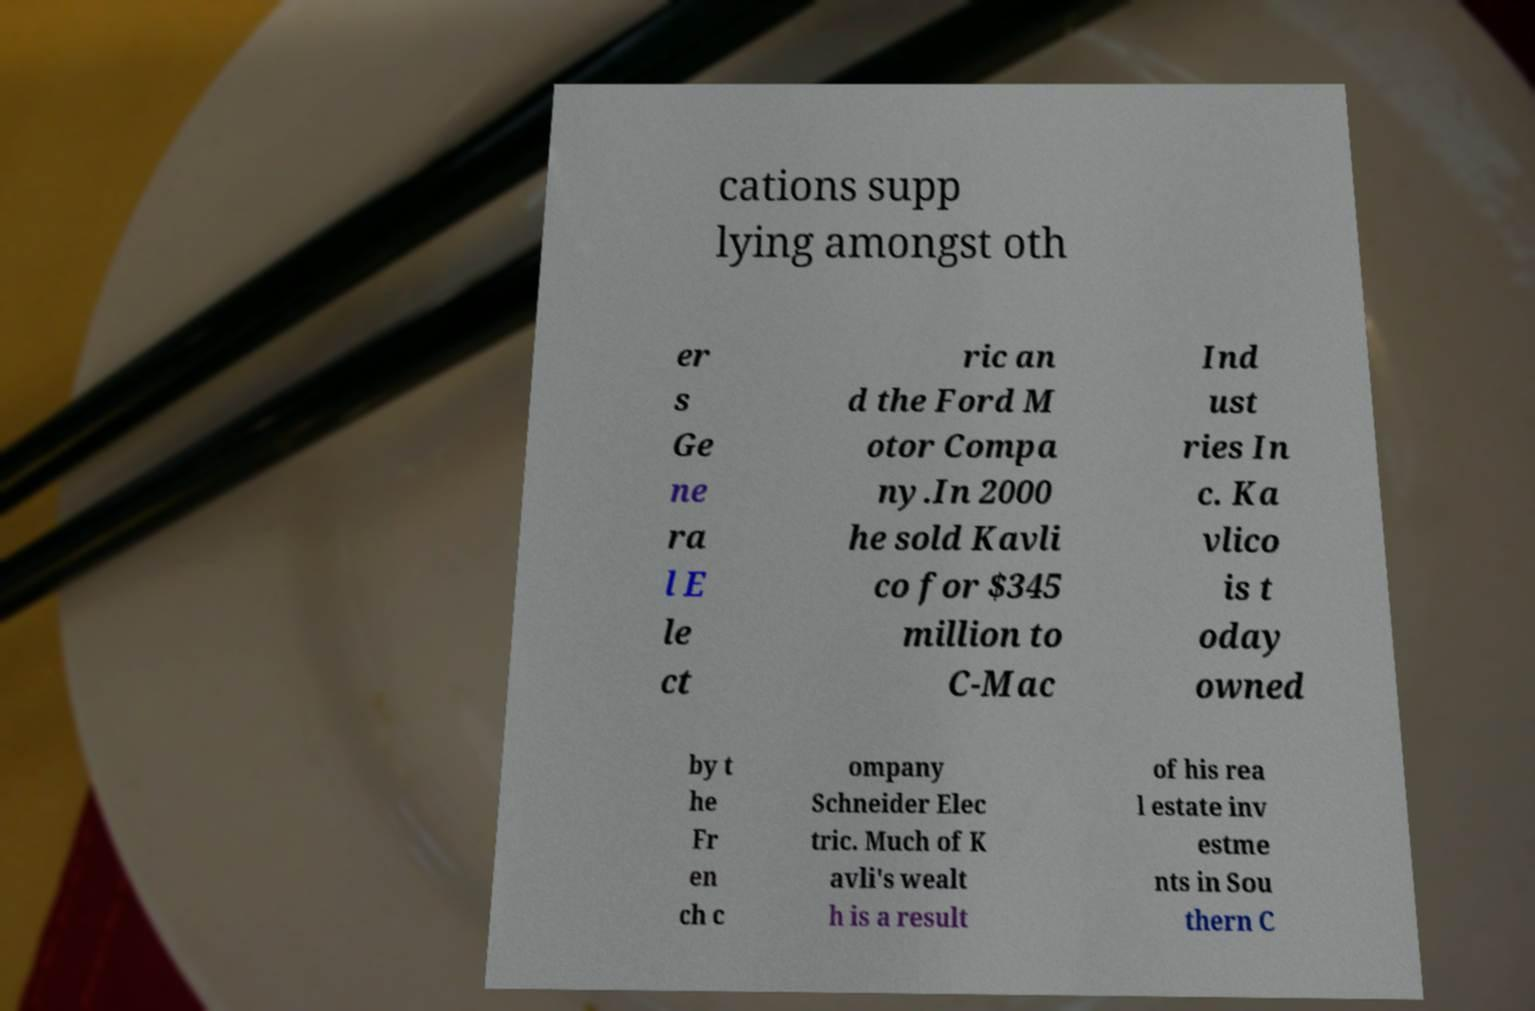I need the written content from this picture converted into text. Can you do that? cations supp lying amongst oth er s Ge ne ra l E le ct ric an d the Ford M otor Compa ny.In 2000 he sold Kavli co for $345 million to C-Mac Ind ust ries In c. Ka vlico is t oday owned by t he Fr en ch c ompany Schneider Elec tric. Much of K avli's wealt h is a result of his rea l estate inv estme nts in Sou thern C 